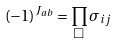Convert formula to latex. <formula><loc_0><loc_0><loc_500><loc_500>( - 1 ) ^ { J _ { a b } } = \prod _ { \Box } \sigma _ { i j }</formula> 